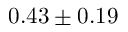Convert formula to latex. <formula><loc_0><loc_0><loc_500><loc_500>0 . 4 3 \pm 0 . 1 9</formula> 